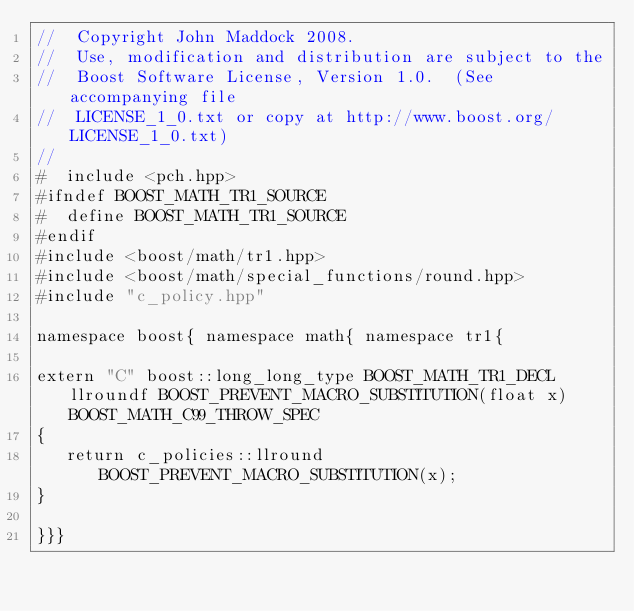<code> <loc_0><loc_0><loc_500><loc_500><_C++_>//  Copyright John Maddock 2008.
//  Use, modification and distribution are subject to the
//  Boost Software License, Version 1.0.  (See accompanying file
//  LICENSE_1_0.txt or copy at http://www.boost.org/LICENSE_1_0.txt)
//
#  include <pch.hpp>
#ifndef BOOST_MATH_TR1_SOURCE
#  define BOOST_MATH_TR1_SOURCE
#endif
#include <boost/math/tr1.hpp>
#include <boost/math/special_functions/round.hpp>
#include "c_policy.hpp"

namespace boost{ namespace math{ namespace tr1{

extern "C" boost::long_long_type BOOST_MATH_TR1_DECL llroundf BOOST_PREVENT_MACRO_SUBSTITUTION(float x) BOOST_MATH_C99_THROW_SPEC
{
   return c_policies::llround BOOST_PREVENT_MACRO_SUBSTITUTION(x);
}

}}}


</code> 